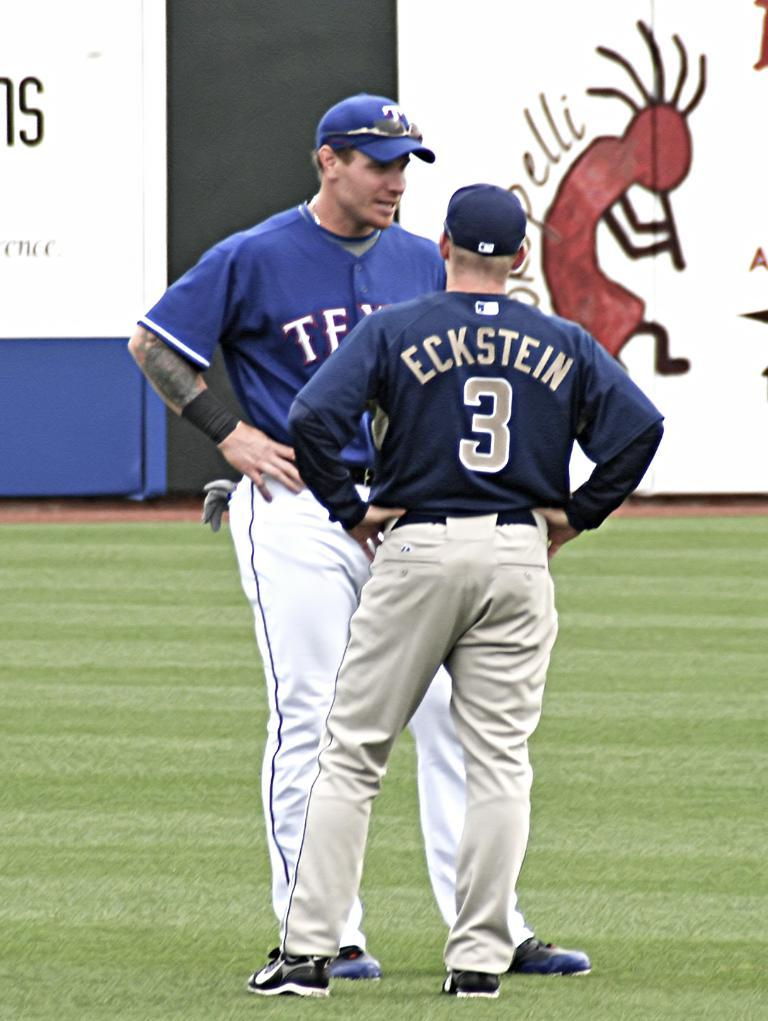How many people are in total are present in the image? There are two persons standing in the image. What is the surface on which the persons are standing? The persons are standing on the ground. What can be seen in the background of the image? There are boards visible in the background of the image. What flavor of friction can be observed between the persons in the image? There is no mention of friction or flavor in the image, as it features two persons standing on the ground with boards visible in the background. 